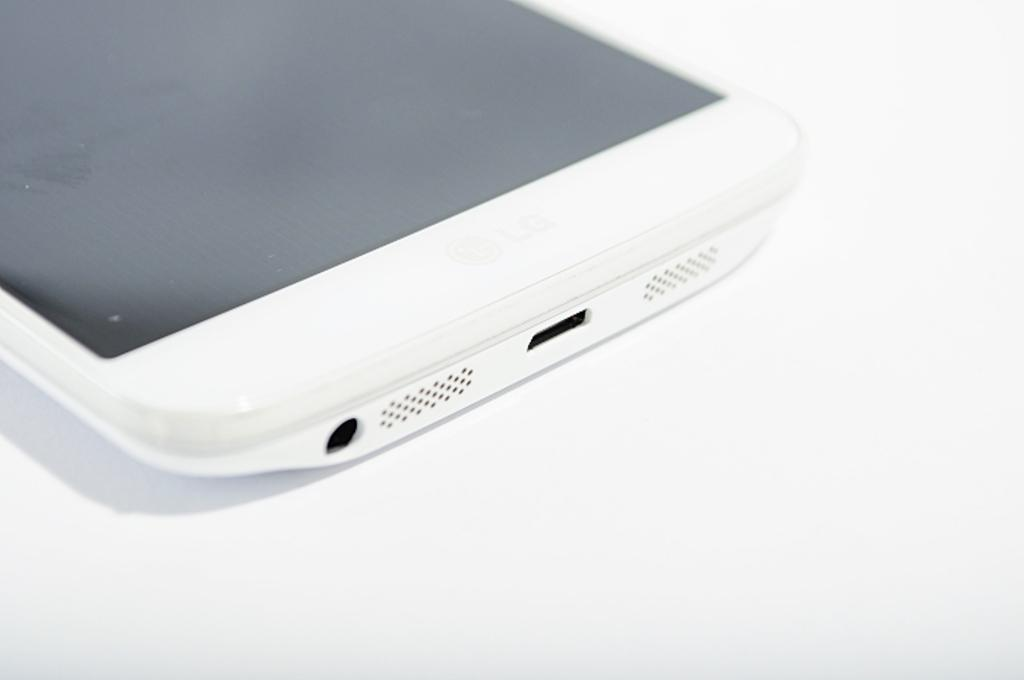What is the main object in the image? There is a mobile in the image. What color is the mobile? The mobile is white in color. What is the background color of the image? The background of the image is white. What is the rate of the camera in the image? There is no camera present in the image, so it's not possible to determine the rate. 